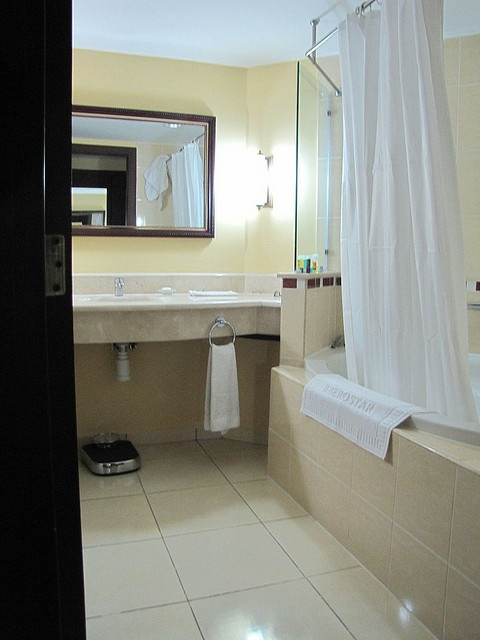Describe the objects in this image and their specific colors. I can see a sink in black, lightgray, and darkgray tones in this image. 